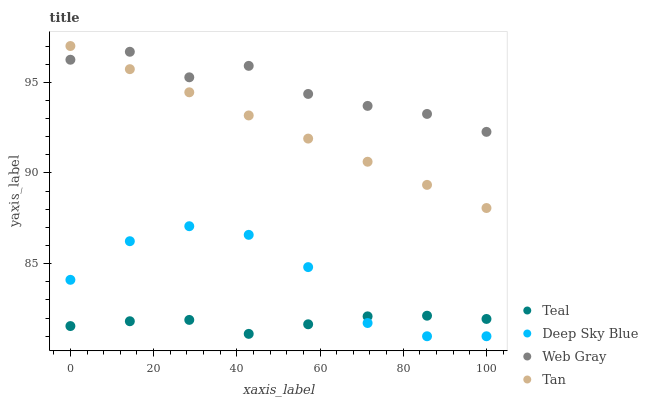Does Teal have the minimum area under the curve?
Answer yes or no. Yes. Does Web Gray have the maximum area under the curve?
Answer yes or no. Yes. Does Deep Sky Blue have the minimum area under the curve?
Answer yes or no. No. Does Deep Sky Blue have the maximum area under the curve?
Answer yes or no. No. Is Tan the smoothest?
Answer yes or no. Yes. Is Deep Sky Blue the roughest?
Answer yes or no. Yes. Is Web Gray the smoothest?
Answer yes or no. No. Is Web Gray the roughest?
Answer yes or no. No. Does Deep Sky Blue have the lowest value?
Answer yes or no. Yes. Does Web Gray have the lowest value?
Answer yes or no. No. Does Tan have the highest value?
Answer yes or no. Yes. Does Web Gray have the highest value?
Answer yes or no. No. Is Deep Sky Blue less than Tan?
Answer yes or no. Yes. Is Tan greater than Teal?
Answer yes or no. Yes. Does Web Gray intersect Tan?
Answer yes or no. Yes. Is Web Gray less than Tan?
Answer yes or no. No. Is Web Gray greater than Tan?
Answer yes or no. No. Does Deep Sky Blue intersect Tan?
Answer yes or no. No. 